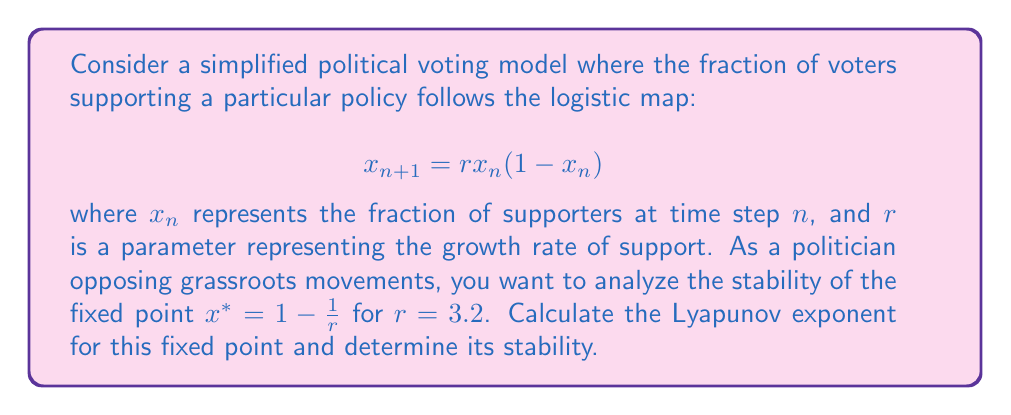Teach me how to tackle this problem. 1. First, we need to find the fixed point $x^*$ for $r = 3.2$:
   $$x^* = 1 - \frac{1}{r} = 1 - \frac{1}{3.2} = 0.6875$$

2. The Lyapunov exponent $\lambda$ for a one-dimensional map is given by:
   $$\lambda = \lim_{N \to \infty} \frac{1}{N} \sum_{n=0}^{N-1} \ln |f'(x_n)|$$

   where $f'(x)$ is the derivative of the map.

3. For the logistic map, $f'(x) = r(1-2x)$

4. At the fixed point $x^*$:
   $$f'(x^*) = 3.2(1-2(0.6875)) = 3.2(-0.375) = -1.2$$

5. Since the fixed point is constant, we can simplify the Lyapunov exponent:
   $$\lambda = \ln |f'(x^*)| = \ln |-1.2| = 0.1823$$

6. Interpretation of the Lyapunov exponent:
   - If $\lambda < 0$, the fixed point is stable.
   - If $\lambda > 0$, the fixed point is unstable.
   - If $\lambda = 0$, the fixed point is neutral.

7. In this case, $\lambda > 0$, indicating that the fixed point is unstable.
Answer: $\lambda \approx 0.1823$; unstable 